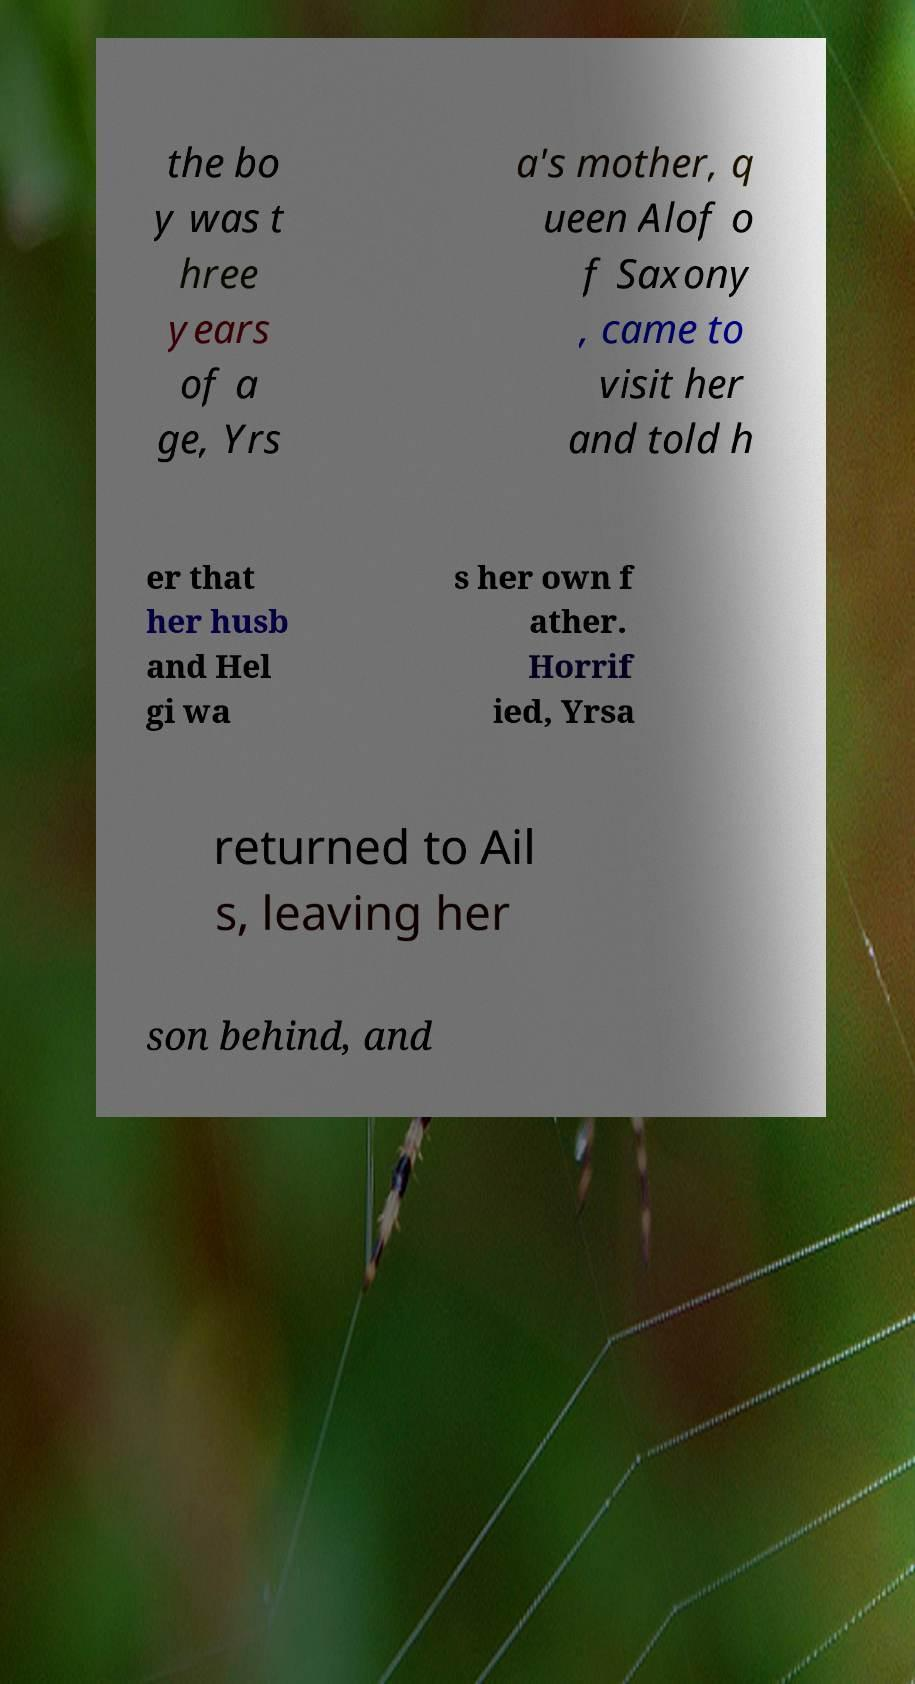There's text embedded in this image that I need extracted. Can you transcribe it verbatim? the bo y was t hree years of a ge, Yrs a's mother, q ueen Alof o f Saxony , came to visit her and told h er that her husb and Hel gi wa s her own f ather. Horrif ied, Yrsa returned to Ail s, leaving her son behind, and 